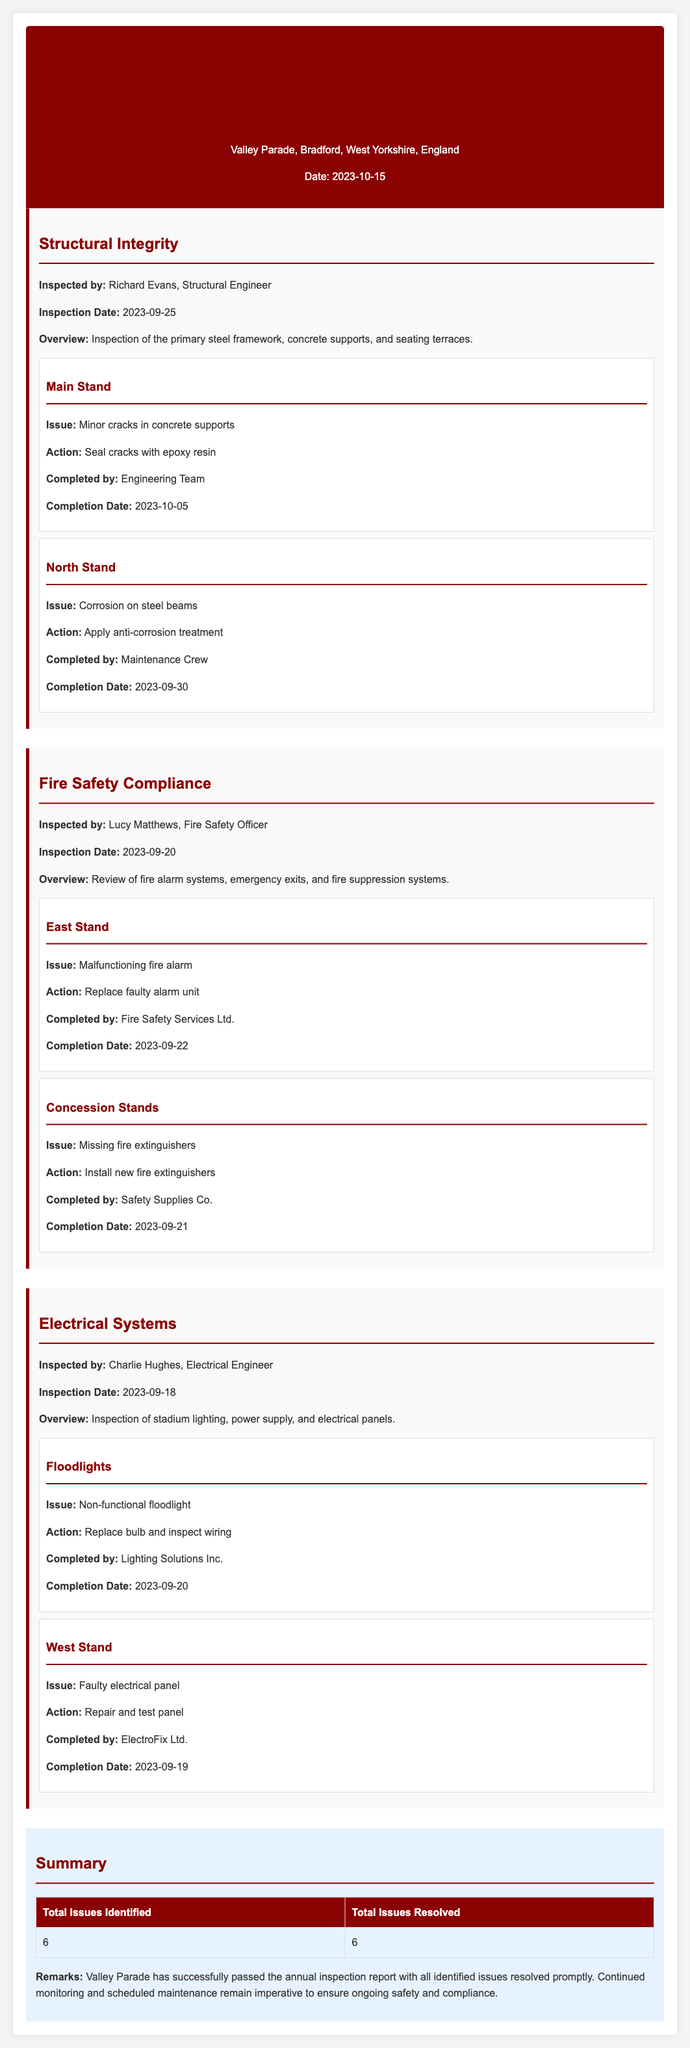What is the date of the inspection report? The date of the inspection report is mentioned at the top of the document as 2023-10-15.
Answer: 2023-10-15 Who inspected the structural integrity? Richard Evans is noted as the structural engineer who conducted the inspection.
Answer: Richard Evans What issue was found in the East Stand? The document states that the issue found in the East Stand was a malfunctioning fire alarm.
Answer: Malfunctioning fire alarm How many total issues were resolved? The summary section of the report indicates that all identified issues were resolved, totaling 6.
Answer: 6 What action was taken for the North Stand? The action taken for the North Stand was to apply anti-corrosion treatment as indicated in the findings section.
Answer: Apply anti-corrosion treatment Who completed the installation of new fire extinguishers? The report specifies that Safety Supplies Co. was responsible for installing the new fire extinguishers.
Answer: Safety Supplies Co What was the completion date for the floodlight issue? The completion date for the floodlight issue is listed as 2023-09-20.
Answer: 2023-09-20 What issue was identified in the Main Stand? The Main Stand was found to have minor cracks in the concrete supports according to the findings.
Answer: Minor cracks in concrete supports Which stand had a faulty electrical panel? The West Stand is where the faulty electrical panel was found during the inspection.
Answer: West Stand 